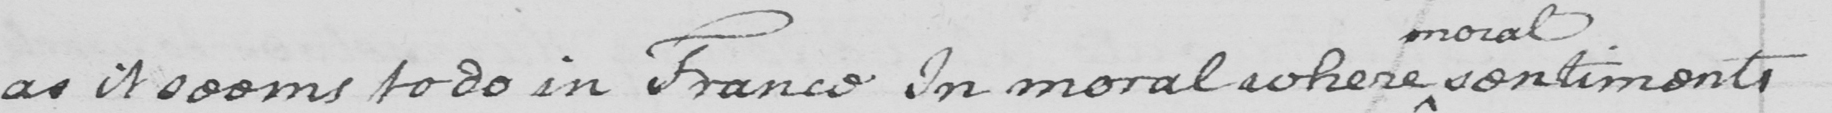What text is written in this handwritten line? as it seems to do in France In moral where sentiments 